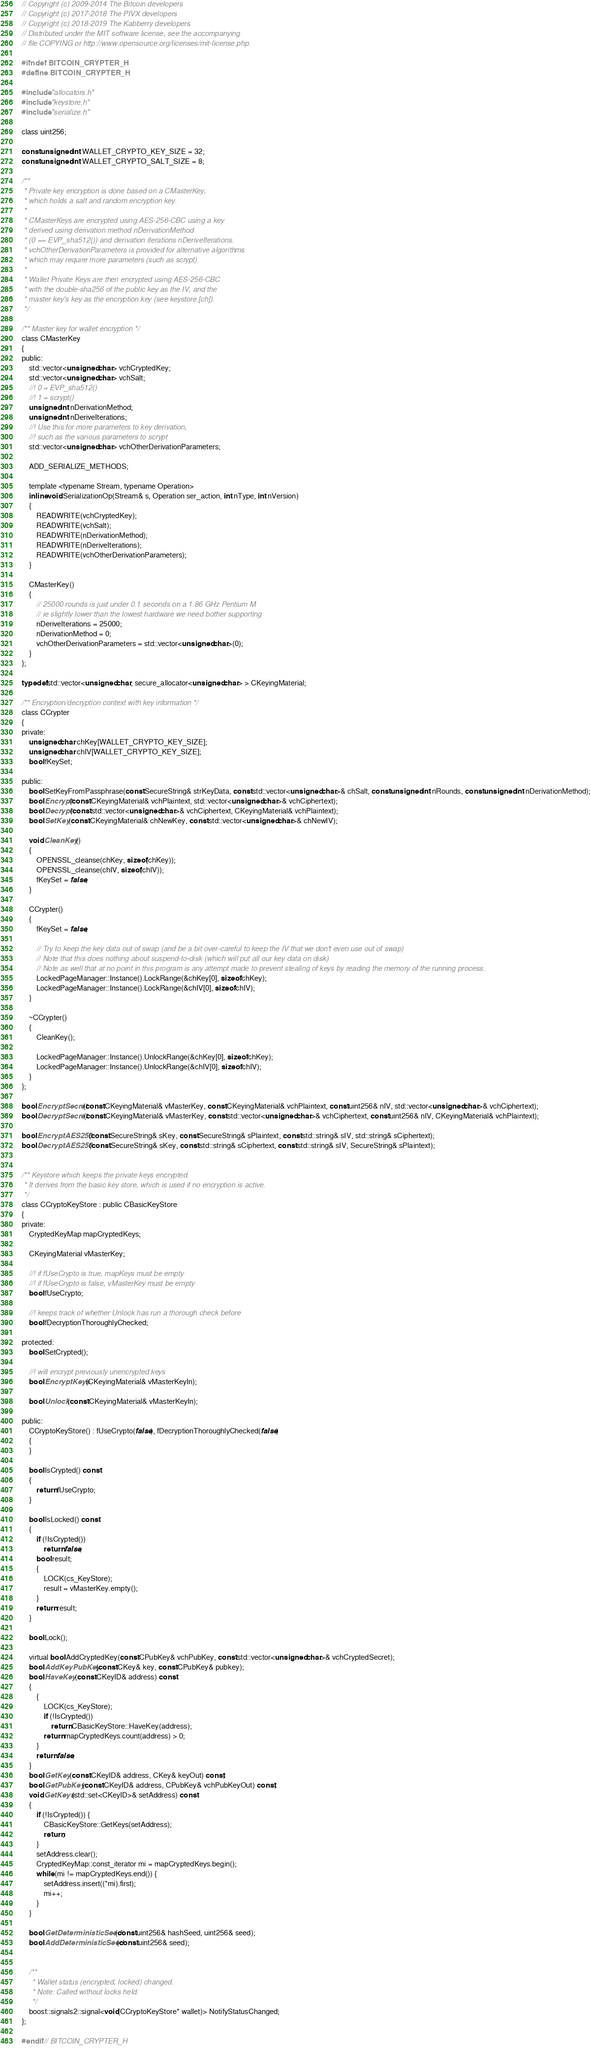<code> <loc_0><loc_0><loc_500><loc_500><_C_>// Copyright (c) 2009-2014 The Bitcoin developers
// Copyright (c) 2017-2018 The PIVX developers
// Copyright (c) 2018-2019 The Kabberry developers
// Distributed under the MIT software license, see the accompanying
// file COPYING or http://www.opensource.org/licenses/mit-license.php.

#ifndef BITCOIN_CRYPTER_H
#define BITCOIN_CRYPTER_H

#include "allocators.h"
#include "keystore.h"
#include "serialize.h"

class uint256;

const unsigned int WALLET_CRYPTO_KEY_SIZE = 32;
const unsigned int WALLET_CRYPTO_SALT_SIZE = 8;

/**
 * Private key encryption is done based on a CMasterKey,
 * which holds a salt and random encryption key.
 * 
 * CMasterKeys are encrypted using AES-256-CBC using a key
 * derived using derivation method nDerivationMethod
 * (0 == EVP_sha512()) and derivation iterations nDeriveIterations.
 * vchOtherDerivationParameters is provided for alternative algorithms
 * which may require more parameters (such as scrypt).
 * 
 * Wallet Private Keys are then encrypted using AES-256-CBC
 * with the double-sha256 of the public key as the IV, and the
 * master key's key as the encryption key (see keystore.[ch]).
 */

/** Master key for wallet encryption */
class CMasterKey
{
public:
    std::vector<unsigned char> vchCryptedKey;
    std::vector<unsigned char> vchSalt;
    //! 0 = EVP_sha512()
    //! 1 = scrypt()
    unsigned int nDerivationMethod;
    unsigned int nDeriveIterations;
    //! Use this for more parameters to key derivation,
    //! such as the various parameters to scrypt
    std::vector<unsigned char> vchOtherDerivationParameters;

    ADD_SERIALIZE_METHODS;

    template <typename Stream, typename Operation>
    inline void SerializationOp(Stream& s, Operation ser_action, int nType, int nVersion)
    {
        READWRITE(vchCryptedKey);
        READWRITE(vchSalt);
        READWRITE(nDerivationMethod);
        READWRITE(nDeriveIterations);
        READWRITE(vchOtherDerivationParameters);
    }

    CMasterKey()
    {
        // 25000 rounds is just under 0.1 seconds on a 1.86 GHz Pentium M
        // ie slightly lower than the lowest hardware we need bother supporting
        nDeriveIterations = 25000;
        nDerivationMethod = 0;
        vchOtherDerivationParameters = std::vector<unsigned char>(0);
    }
};

typedef std::vector<unsigned char, secure_allocator<unsigned char> > CKeyingMaterial;

/** Encryption/decryption context with key information */
class CCrypter
{
private:
    unsigned char chKey[WALLET_CRYPTO_KEY_SIZE];
    unsigned char chIV[WALLET_CRYPTO_KEY_SIZE];
    bool fKeySet;

public:
    bool SetKeyFromPassphrase(const SecureString& strKeyData, const std::vector<unsigned char>& chSalt, const unsigned int nRounds, const unsigned int nDerivationMethod);
    bool Encrypt(const CKeyingMaterial& vchPlaintext, std::vector<unsigned char>& vchCiphertext);
    bool Decrypt(const std::vector<unsigned char>& vchCiphertext, CKeyingMaterial& vchPlaintext);
    bool SetKey(const CKeyingMaterial& chNewKey, const std::vector<unsigned char>& chNewIV);

    void CleanKey()
    {
        OPENSSL_cleanse(chKey, sizeof(chKey));
        OPENSSL_cleanse(chIV, sizeof(chIV));
        fKeySet = false;
    }

    CCrypter()
    {
        fKeySet = false;

        // Try to keep the key data out of swap (and be a bit over-careful to keep the IV that we don't even use out of swap)
        // Note that this does nothing about suspend-to-disk (which will put all our key data on disk)
        // Note as well that at no point in this program is any attempt made to prevent stealing of keys by reading the memory of the running process.
        LockedPageManager::Instance().LockRange(&chKey[0], sizeof chKey);
        LockedPageManager::Instance().LockRange(&chIV[0], sizeof chIV);
    }

    ~CCrypter()
    {
        CleanKey();

        LockedPageManager::Instance().UnlockRange(&chKey[0], sizeof chKey);
        LockedPageManager::Instance().UnlockRange(&chIV[0], sizeof chIV);
    }
};

bool EncryptSecret(const CKeyingMaterial& vMasterKey, const CKeyingMaterial& vchPlaintext, const uint256& nIV, std::vector<unsigned char>& vchCiphertext);
bool DecryptSecret(const CKeyingMaterial& vMasterKey, const std::vector<unsigned char>& vchCiphertext, const uint256& nIV, CKeyingMaterial& vchPlaintext);

bool EncryptAES256(const SecureString& sKey, const SecureString& sPlaintext, const std::string& sIV, std::string& sCiphertext);
bool DecryptAES256(const SecureString& sKey, const std::string& sCiphertext, const std::string& sIV, SecureString& sPlaintext);


/** Keystore which keeps the private keys encrypted.
 * It derives from the basic key store, which is used if no encryption is active.
 */
class CCryptoKeyStore : public CBasicKeyStore
{
private:
    CryptedKeyMap mapCryptedKeys;

    CKeyingMaterial vMasterKey;

    //! if fUseCrypto is true, mapKeys must be empty
    //! if fUseCrypto is false, vMasterKey must be empty
    bool fUseCrypto;

    //! keeps track of whether Unlock has run a thorough check before
    bool fDecryptionThoroughlyChecked;

protected:
    bool SetCrypted();

    //! will encrypt previously unencrypted keys
    bool EncryptKeys(CKeyingMaterial& vMasterKeyIn);

    bool Unlock(const CKeyingMaterial& vMasterKeyIn);

public:
    CCryptoKeyStore() : fUseCrypto(false), fDecryptionThoroughlyChecked(false)
    {
    }

    bool IsCrypted() const
    {
        return fUseCrypto;
    }

    bool IsLocked() const
    {
        if (!IsCrypted())
            return false;
        bool result;
        {
            LOCK(cs_KeyStore);
            result = vMasterKey.empty();
        }
        return result;
    }

    bool Lock();

    virtual bool AddCryptedKey(const CPubKey& vchPubKey, const std::vector<unsigned char>& vchCryptedSecret);
    bool AddKeyPubKey(const CKey& key, const CPubKey& pubkey);
    bool HaveKey(const CKeyID& address) const
    {
        {
            LOCK(cs_KeyStore);
            if (!IsCrypted())
                return CBasicKeyStore::HaveKey(address);
            return mapCryptedKeys.count(address) > 0;
        }
        return false;
    }
    bool GetKey(const CKeyID& address, CKey& keyOut) const;
    bool GetPubKey(const CKeyID& address, CPubKey& vchPubKeyOut) const;
    void GetKeys(std::set<CKeyID>& setAddress) const
    {
        if (!IsCrypted()) {
            CBasicKeyStore::GetKeys(setAddress);
            return;
        }
        setAddress.clear();
        CryptedKeyMap::const_iterator mi = mapCryptedKeys.begin();
        while (mi != mapCryptedKeys.end()) {
            setAddress.insert((*mi).first);
            mi++;
        }
    }

    bool GetDeterministicSeed(const uint256& hashSeed, uint256& seed);
    bool AddDeterministicSeed(const uint256& seed);


    /**
     * Wallet status (encrypted, locked) changed.
     * Note: Called without locks held.
     */
    boost::signals2::signal<void(CCryptoKeyStore* wallet)> NotifyStatusChanged;
};

#endif // BITCOIN_CRYPTER_H
</code> 